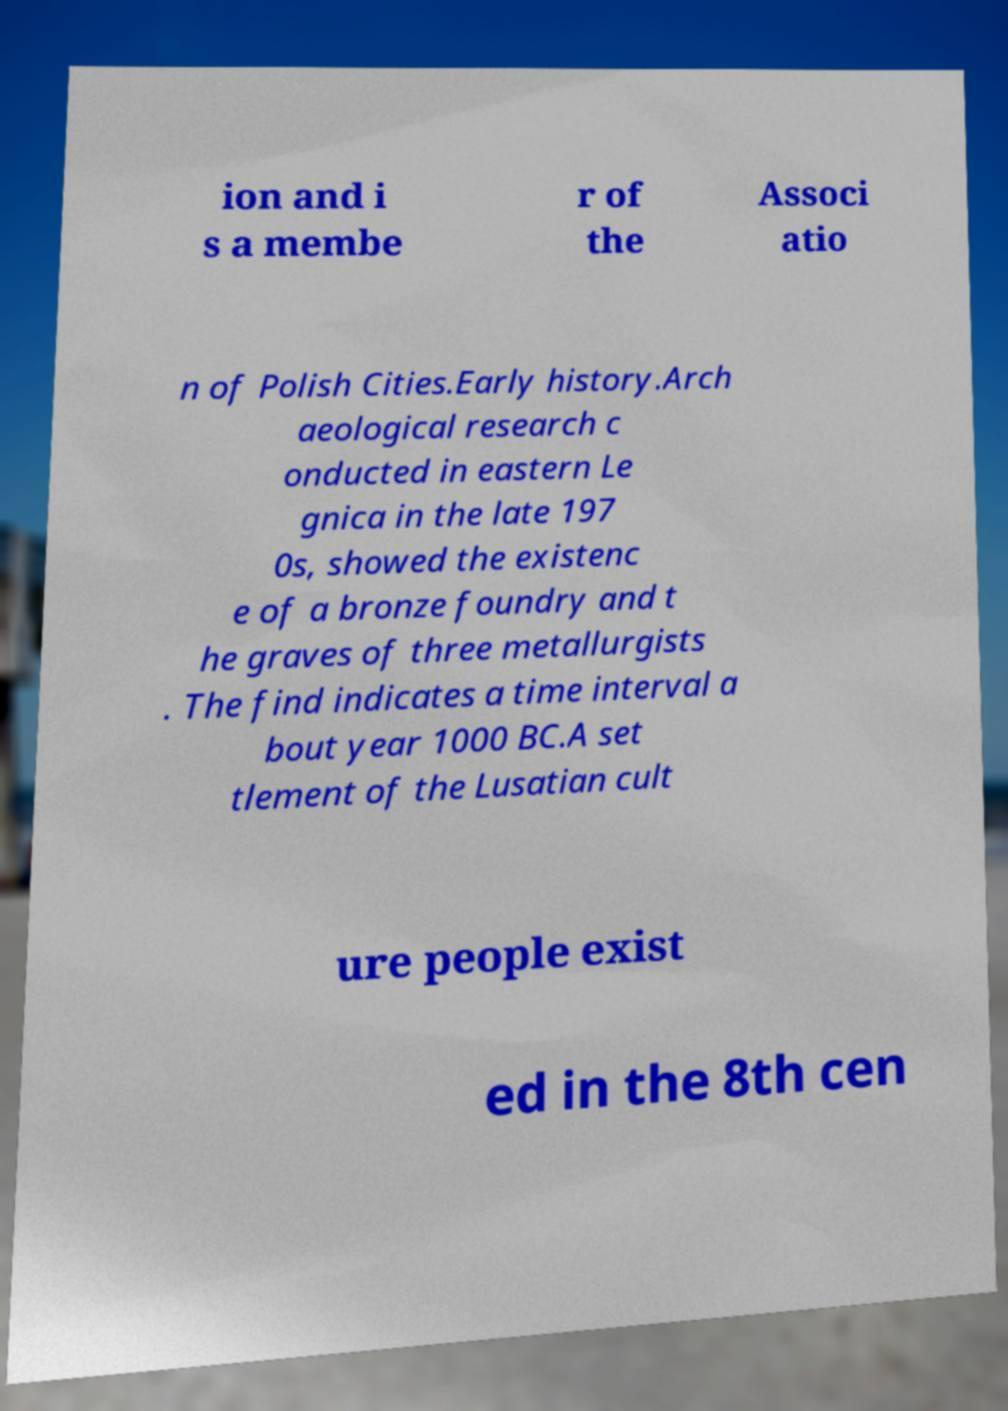What messages or text are displayed in this image? I need them in a readable, typed format. ion and i s a membe r of the Associ atio n of Polish Cities.Early history.Arch aeological research c onducted in eastern Le gnica in the late 197 0s, showed the existenc e of a bronze foundry and t he graves of three metallurgists . The find indicates a time interval a bout year 1000 BC.A set tlement of the Lusatian cult ure people exist ed in the 8th cen 